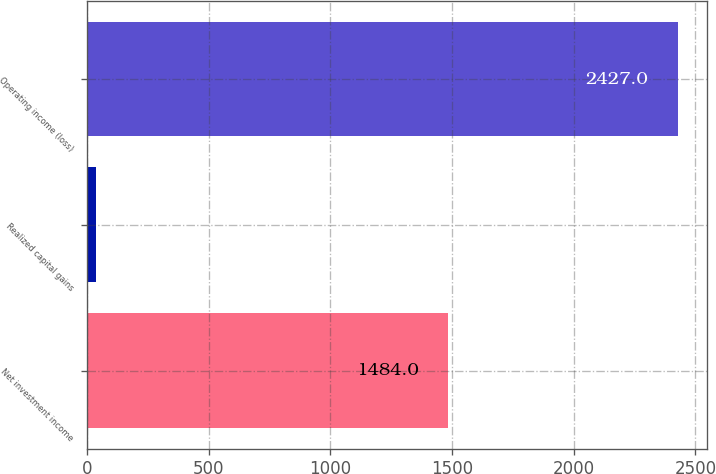Convert chart to OTSL. <chart><loc_0><loc_0><loc_500><loc_500><bar_chart><fcel>Net investment income<fcel>Realized capital gains<fcel>Operating income (loss)<nl><fcel>1484<fcel>37<fcel>2427<nl></chart> 